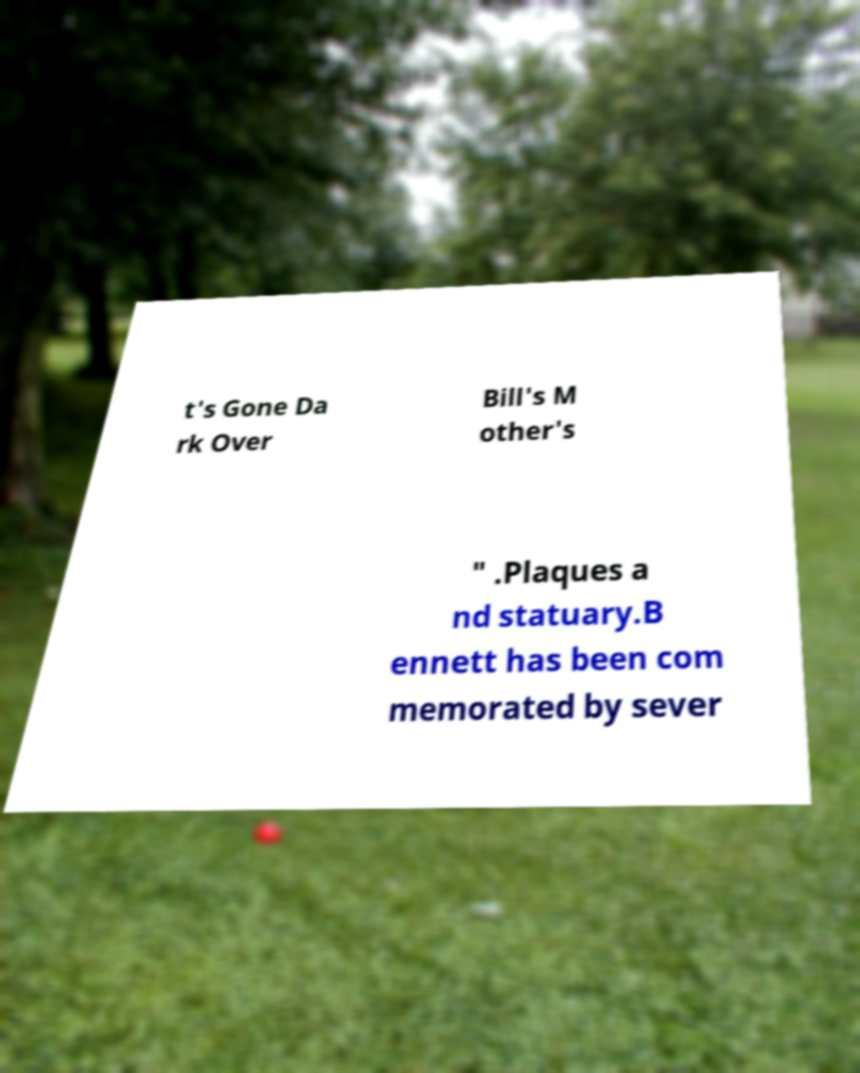Could you extract and type out the text from this image? t's Gone Da rk Over Bill's M other's " .Plaques a nd statuary.B ennett has been com memorated by sever 